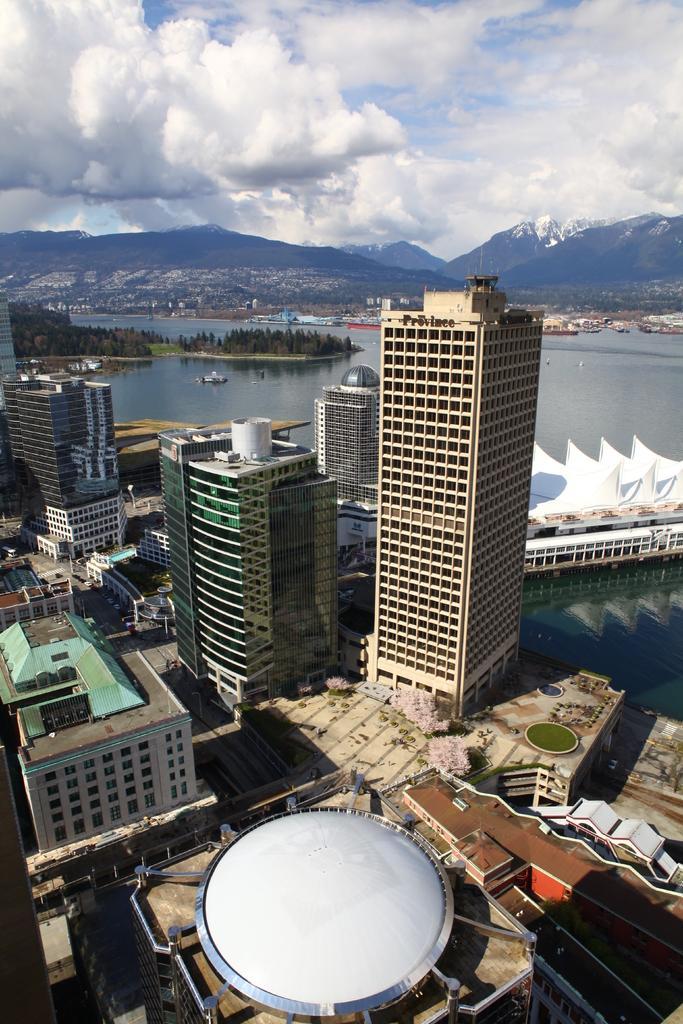Please provide a concise description of this image. As we can see in the image there are buildings, boats, water, trees and hills. On the top there is sky and clouds. 